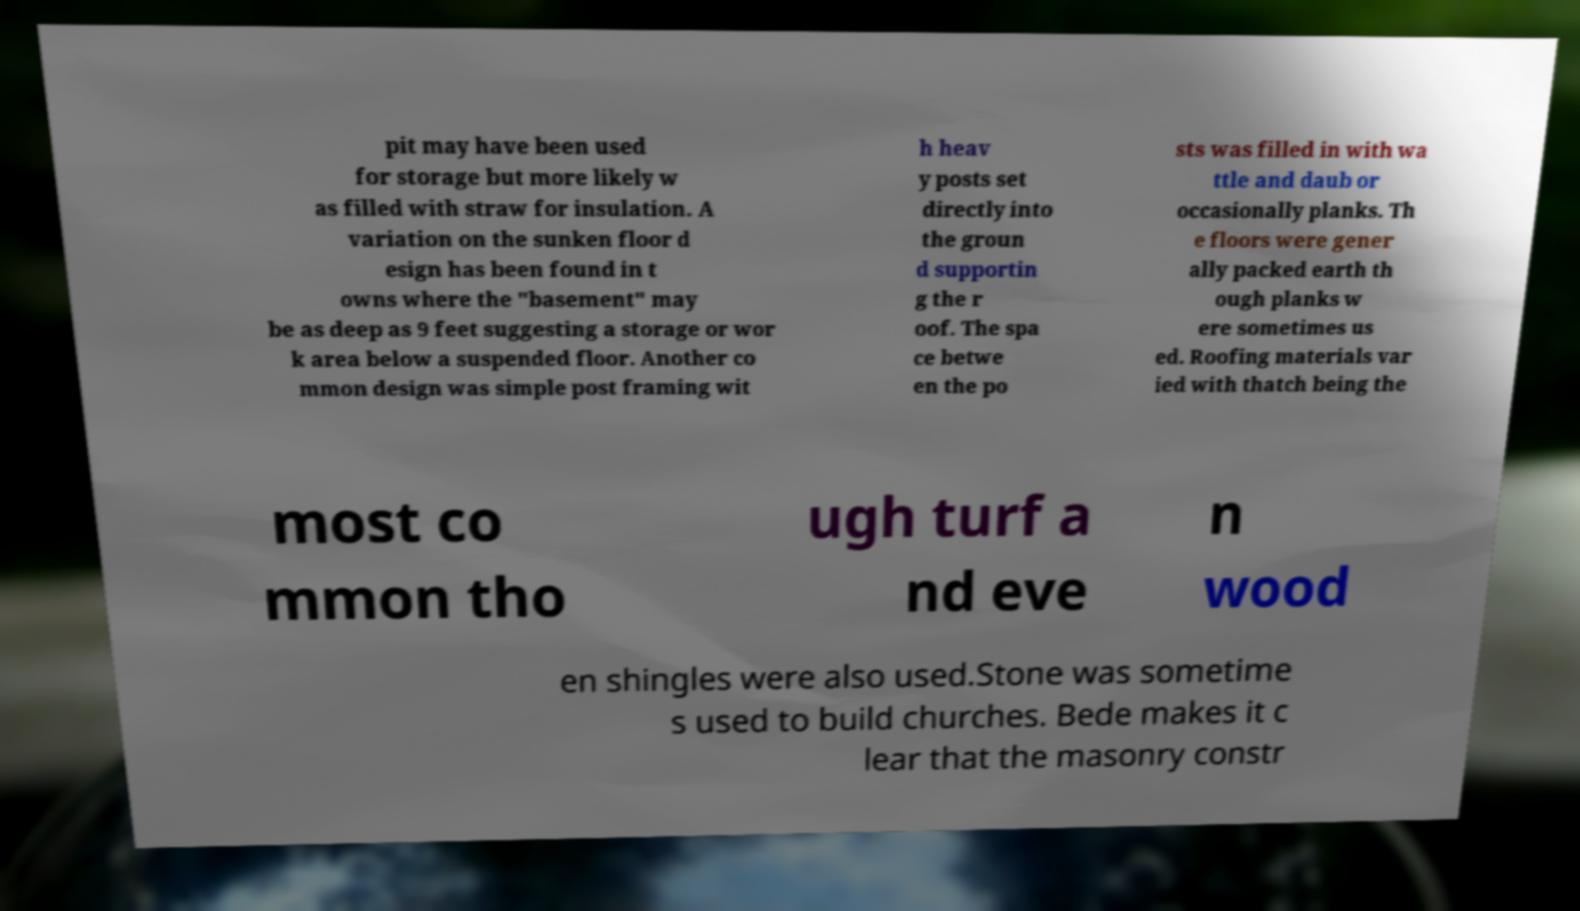There's text embedded in this image that I need extracted. Can you transcribe it verbatim? pit may have been used for storage but more likely w as filled with straw for insulation. A variation on the sunken floor d esign has been found in t owns where the "basement" may be as deep as 9 feet suggesting a storage or wor k area below a suspended floor. Another co mmon design was simple post framing wit h heav y posts set directly into the groun d supportin g the r oof. The spa ce betwe en the po sts was filled in with wa ttle and daub or occasionally planks. Th e floors were gener ally packed earth th ough planks w ere sometimes us ed. Roofing materials var ied with thatch being the most co mmon tho ugh turf a nd eve n wood en shingles were also used.Stone was sometime s used to build churches. Bede makes it c lear that the masonry constr 